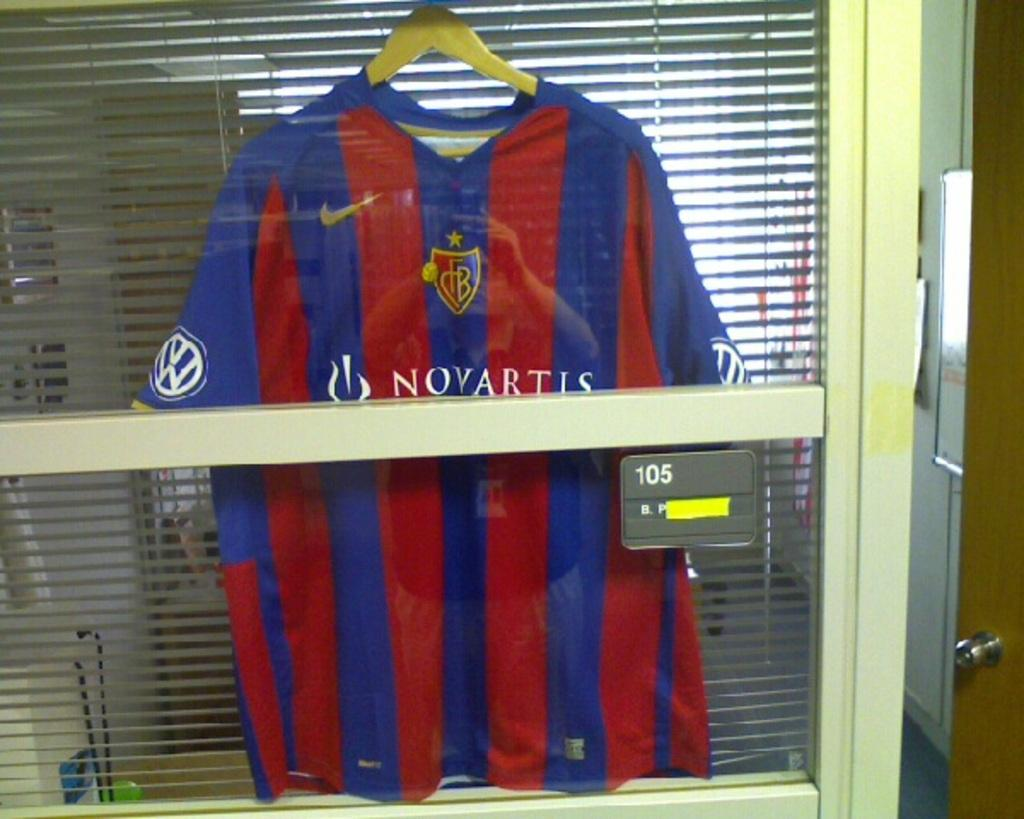<image>
Offer a succinct explanation of the picture presented. A blue and red striped shirt with Novartis written on it. 